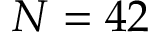<formula> <loc_0><loc_0><loc_500><loc_500>N = 4 2</formula> 